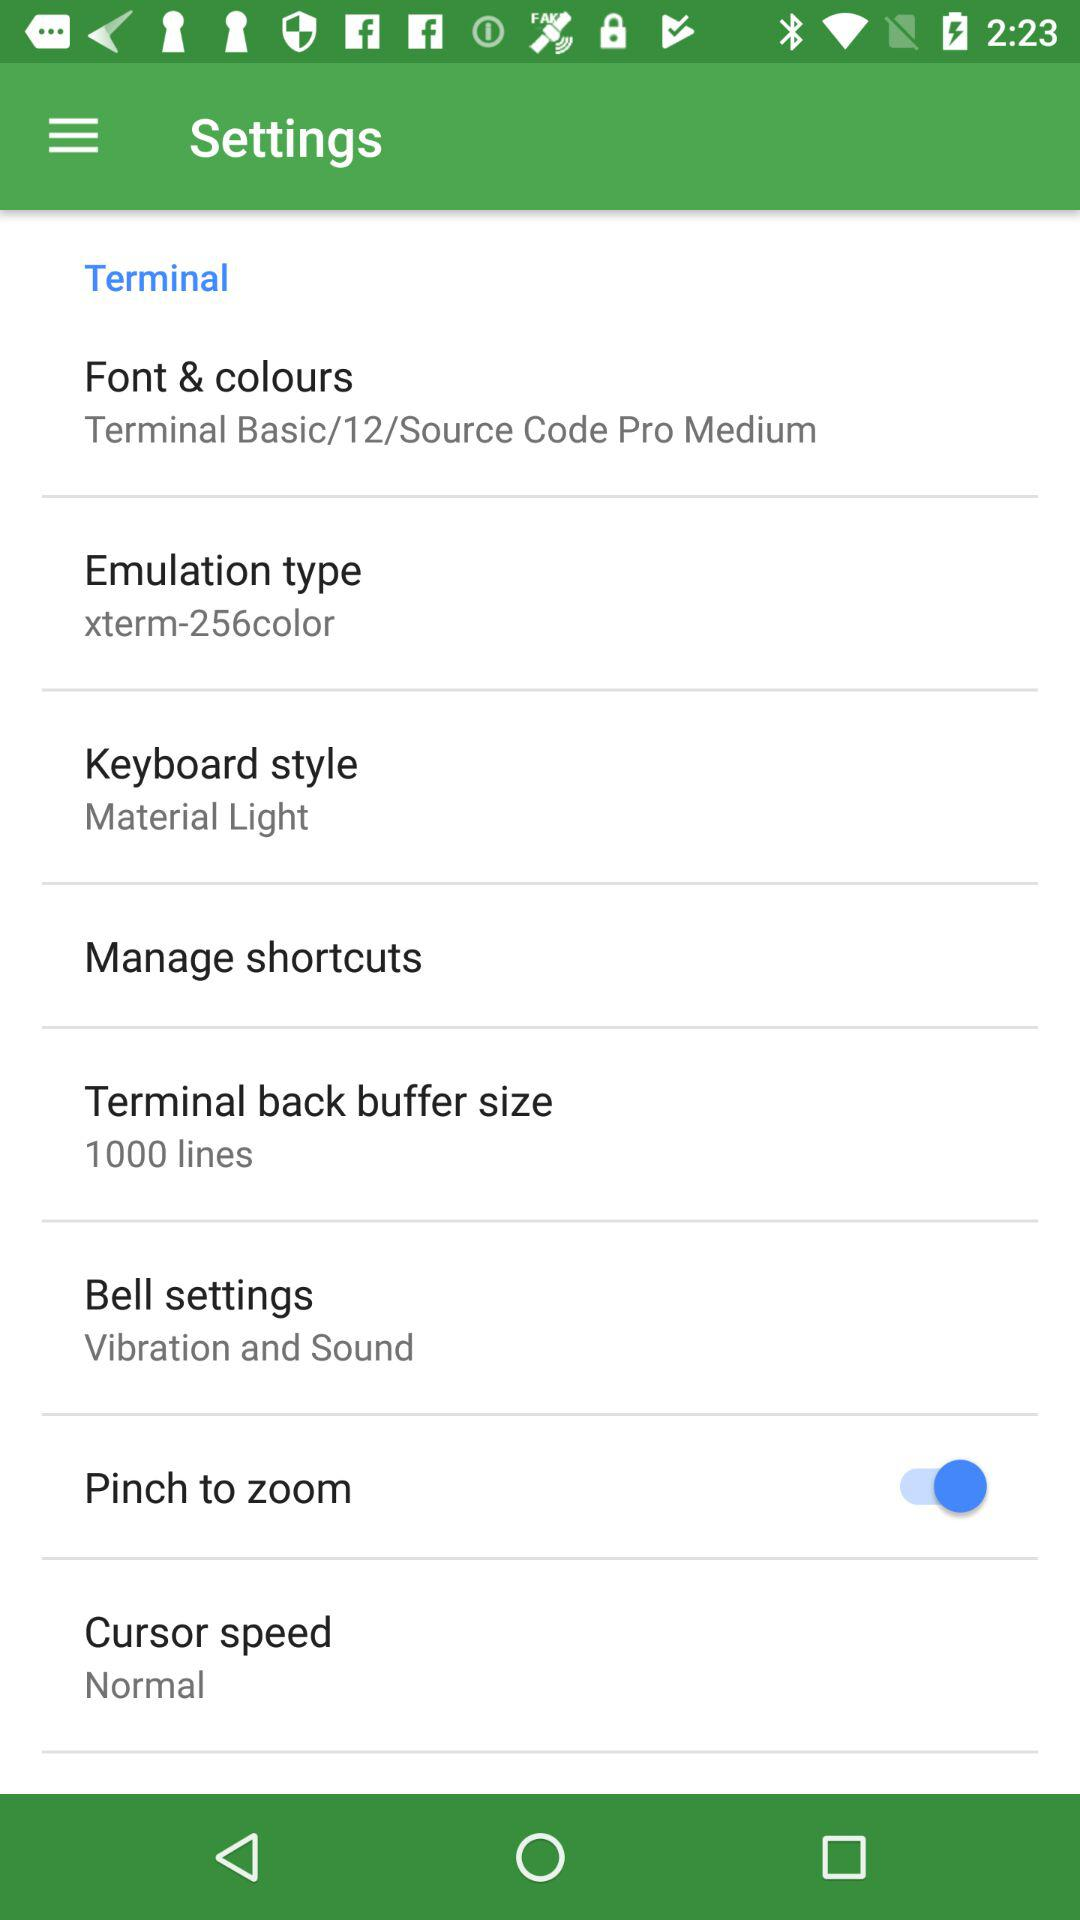How many shortcuts are available?
When the provided information is insufficient, respond with <no answer>. <no answer> 